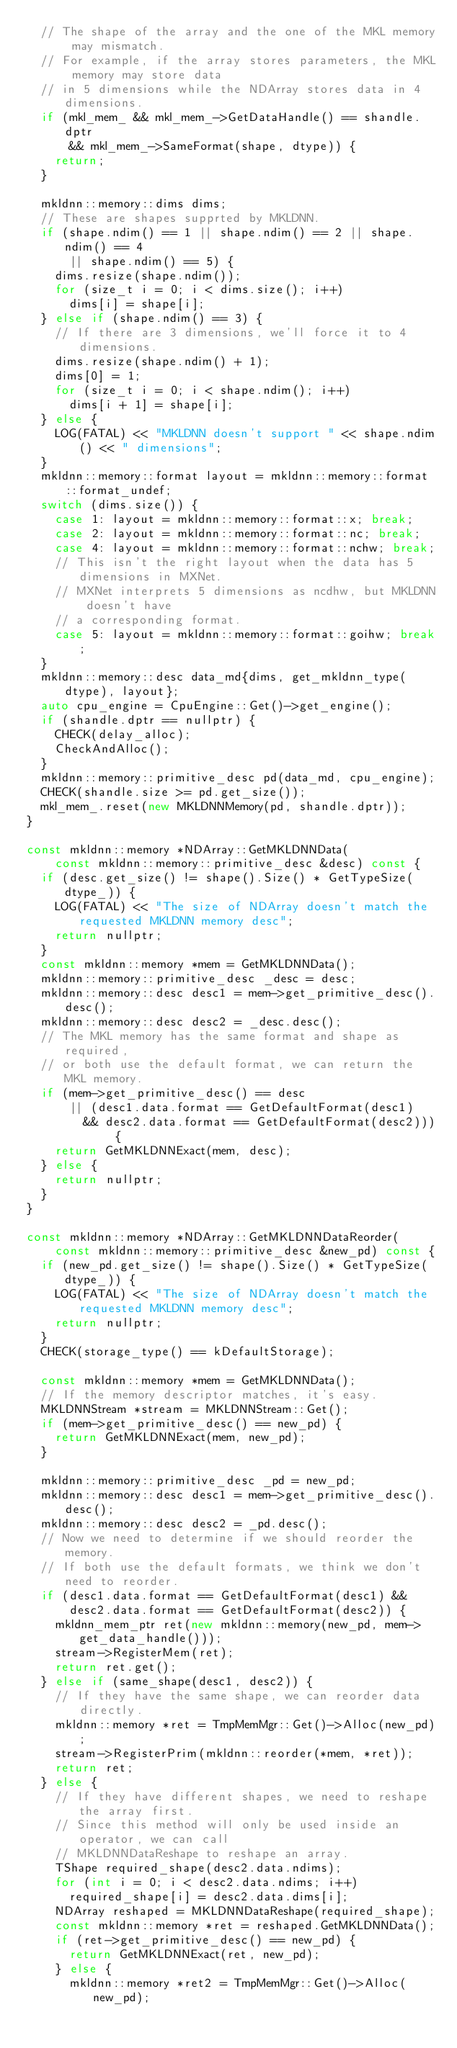Convert code to text. <code><loc_0><loc_0><loc_500><loc_500><_C++_>  // The shape of the array and the one of the MKL memory may mismatch.
  // For example, if the array stores parameters, the MKL memory may store data
  // in 5 dimensions while the NDArray stores data in 4 dimensions.
  if (mkl_mem_ && mkl_mem_->GetDataHandle() == shandle.dptr
      && mkl_mem_->SameFormat(shape, dtype)) {
    return;
  }

  mkldnn::memory::dims dims;
  // These are shapes supprted by MKLDNN.
  if (shape.ndim() == 1 || shape.ndim() == 2 || shape.ndim() == 4
      || shape.ndim() == 5) {
    dims.resize(shape.ndim());
    for (size_t i = 0; i < dims.size(); i++)
      dims[i] = shape[i];
  } else if (shape.ndim() == 3) {
    // If there are 3 dimensions, we'll force it to 4 dimensions.
    dims.resize(shape.ndim() + 1);
    dims[0] = 1;
    for (size_t i = 0; i < shape.ndim(); i++)
      dims[i + 1] = shape[i];
  } else {
    LOG(FATAL) << "MKLDNN doesn't support " << shape.ndim() << " dimensions";
  }
  mkldnn::memory::format layout = mkldnn::memory::format::format_undef;
  switch (dims.size()) {
    case 1: layout = mkldnn::memory::format::x; break;
    case 2: layout = mkldnn::memory::format::nc; break;
    case 4: layout = mkldnn::memory::format::nchw; break;
    // This isn't the right layout when the data has 5 dimensions in MXNet.
    // MXNet interprets 5 dimensions as ncdhw, but MKLDNN doesn't have
    // a corresponding format.
    case 5: layout = mkldnn::memory::format::goihw; break;
  }
  mkldnn::memory::desc data_md{dims, get_mkldnn_type(dtype), layout};
  auto cpu_engine = CpuEngine::Get()->get_engine();
  if (shandle.dptr == nullptr) {
    CHECK(delay_alloc);
    CheckAndAlloc();
  }
  mkldnn::memory::primitive_desc pd(data_md, cpu_engine);
  CHECK(shandle.size >= pd.get_size());
  mkl_mem_.reset(new MKLDNNMemory(pd, shandle.dptr));
}

const mkldnn::memory *NDArray::GetMKLDNNData(
    const mkldnn::memory::primitive_desc &desc) const {
  if (desc.get_size() != shape().Size() * GetTypeSize(dtype_)) {
    LOG(FATAL) << "The size of NDArray doesn't match the requested MKLDNN memory desc";
    return nullptr;
  }
  const mkldnn::memory *mem = GetMKLDNNData();
  mkldnn::memory::primitive_desc _desc = desc;
  mkldnn::memory::desc desc1 = mem->get_primitive_desc().desc();
  mkldnn::memory::desc desc2 = _desc.desc();
  // The MKL memory has the same format and shape as required,
  // or both use the default format, we can return the MKL memory.
  if (mem->get_primitive_desc() == desc
      || (desc1.data.format == GetDefaultFormat(desc1)
        && desc2.data.format == GetDefaultFormat(desc2))) {
    return GetMKLDNNExact(mem, desc);
  } else {
    return nullptr;
  }
}

const mkldnn::memory *NDArray::GetMKLDNNDataReorder(
    const mkldnn::memory::primitive_desc &new_pd) const {
  if (new_pd.get_size() != shape().Size() * GetTypeSize(dtype_)) {
    LOG(FATAL) << "The size of NDArray doesn't match the requested MKLDNN memory desc";
    return nullptr;
  }
  CHECK(storage_type() == kDefaultStorage);

  const mkldnn::memory *mem = GetMKLDNNData();
  // If the memory descriptor matches, it's easy.
  MKLDNNStream *stream = MKLDNNStream::Get();
  if (mem->get_primitive_desc() == new_pd) {
    return GetMKLDNNExact(mem, new_pd);
  }

  mkldnn::memory::primitive_desc _pd = new_pd;
  mkldnn::memory::desc desc1 = mem->get_primitive_desc().desc();
  mkldnn::memory::desc desc2 = _pd.desc();
  // Now we need to determine if we should reorder the memory.
  // If both use the default formats, we think we don't need to reorder.
  if (desc1.data.format == GetDefaultFormat(desc1) &&
      desc2.data.format == GetDefaultFormat(desc2)) {
    mkldnn_mem_ptr ret(new mkldnn::memory(new_pd, mem->get_data_handle()));
    stream->RegisterMem(ret);
    return ret.get();
  } else if (same_shape(desc1, desc2)) {
    // If they have the same shape, we can reorder data directly.
    mkldnn::memory *ret = TmpMemMgr::Get()->Alloc(new_pd);
    stream->RegisterPrim(mkldnn::reorder(*mem, *ret));
    return ret;
  } else {
    // If they have different shapes, we need to reshape the array first.
    // Since this method will only be used inside an operator, we can call
    // MKLDNNDataReshape to reshape an array.
    TShape required_shape(desc2.data.ndims);
    for (int i = 0; i < desc2.data.ndims; i++)
      required_shape[i] = desc2.data.dims[i];
    NDArray reshaped = MKLDNNDataReshape(required_shape);
    const mkldnn::memory *ret = reshaped.GetMKLDNNData();
    if (ret->get_primitive_desc() == new_pd) {
      return GetMKLDNNExact(ret, new_pd);
    } else {
      mkldnn::memory *ret2 = TmpMemMgr::Get()->Alloc(new_pd);</code> 